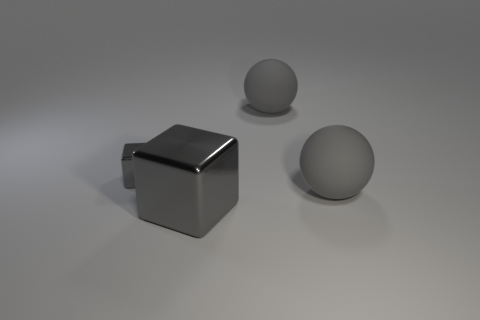There is a gray block that is on the right side of the gray shiny cube on the left side of the large gray block; how big is it?
Provide a succinct answer. Large. Are there more things that are to the right of the small cube than shiny things that are behind the big gray block?
Provide a succinct answer. Yes. What number of blocks are tiny things or gray objects?
Your answer should be compact. 2. Is the shape of the big gray matte object that is in front of the tiny gray metal cube the same as  the small gray metal object?
Make the answer very short. No. The small shiny object is what color?
Offer a terse response. Gray. There is a large thing that is the same shape as the tiny gray thing; what is its color?
Provide a short and direct response. Gray. How many tiny cyan things are the same shape as the small gray shiny thing?
Offer a terse response. 0. How many things are large brown metal cylinders or gray balls behind the small metallic cube?
Provide a short and direct response. 1. Is the color of the small block the same as the large rubber thing that is in front of the small gray object?
Your response must be concise. Yes. Are there any large gray objects behind the small gray metallic cube?
Provide a short and direct response. Yes. 